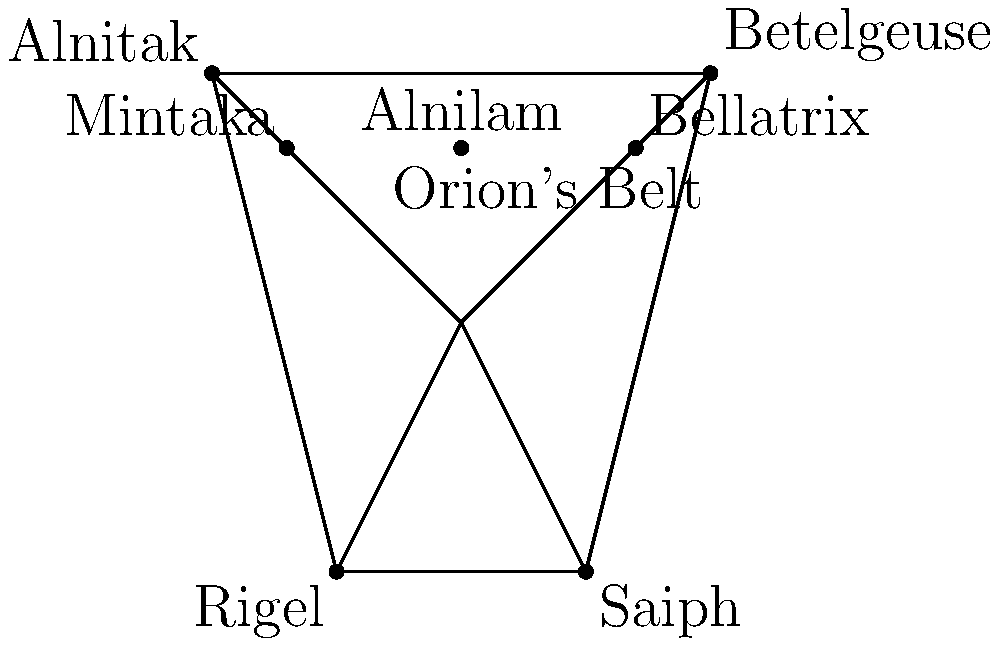In the constellation Orion, which star forms the "right shoulder" of the celestial hunter and is known for its distinctive reddish hue, reminiscent of the power and intensity often associated with martial arts? To answer this question, let's break it down step-by-step:

1. The constellation Orion represents a celestial hunter in many cultures. Its distinctive shape is often described as an hourglass or human figure.

2. The main stars in Orion form a rough rectangle with three bright stars in the middle, known as Orion's Belt.

3. The "shoulders" of Orion are represented by two bright stars at the top of the rectangle:
   - The left shoulder is Betelgeuse
   - The right shoulder is Bellatrix

4. Of these two stars, Betelgeuse is known for its distinctive reddish color. This red hue is due to its status as a red supergiant star.

5. The reddish color of Betelgeuse can be associated with the intensity and power often symbolized in martial arts, where red often represents energy, strength, and passion.

6. Betelgeuse is located at the top right of the constellation from the observer's perspective, which corresponds to Orion's left shoulder. However, when describing the constellation itself, we refer to it as the "right shoulder" of the figure.

Given these facts, the star that forms the "right shoulder" of Orion and is known for its reddish hue is Betelgeuse.
Answer: Betelgeuse 